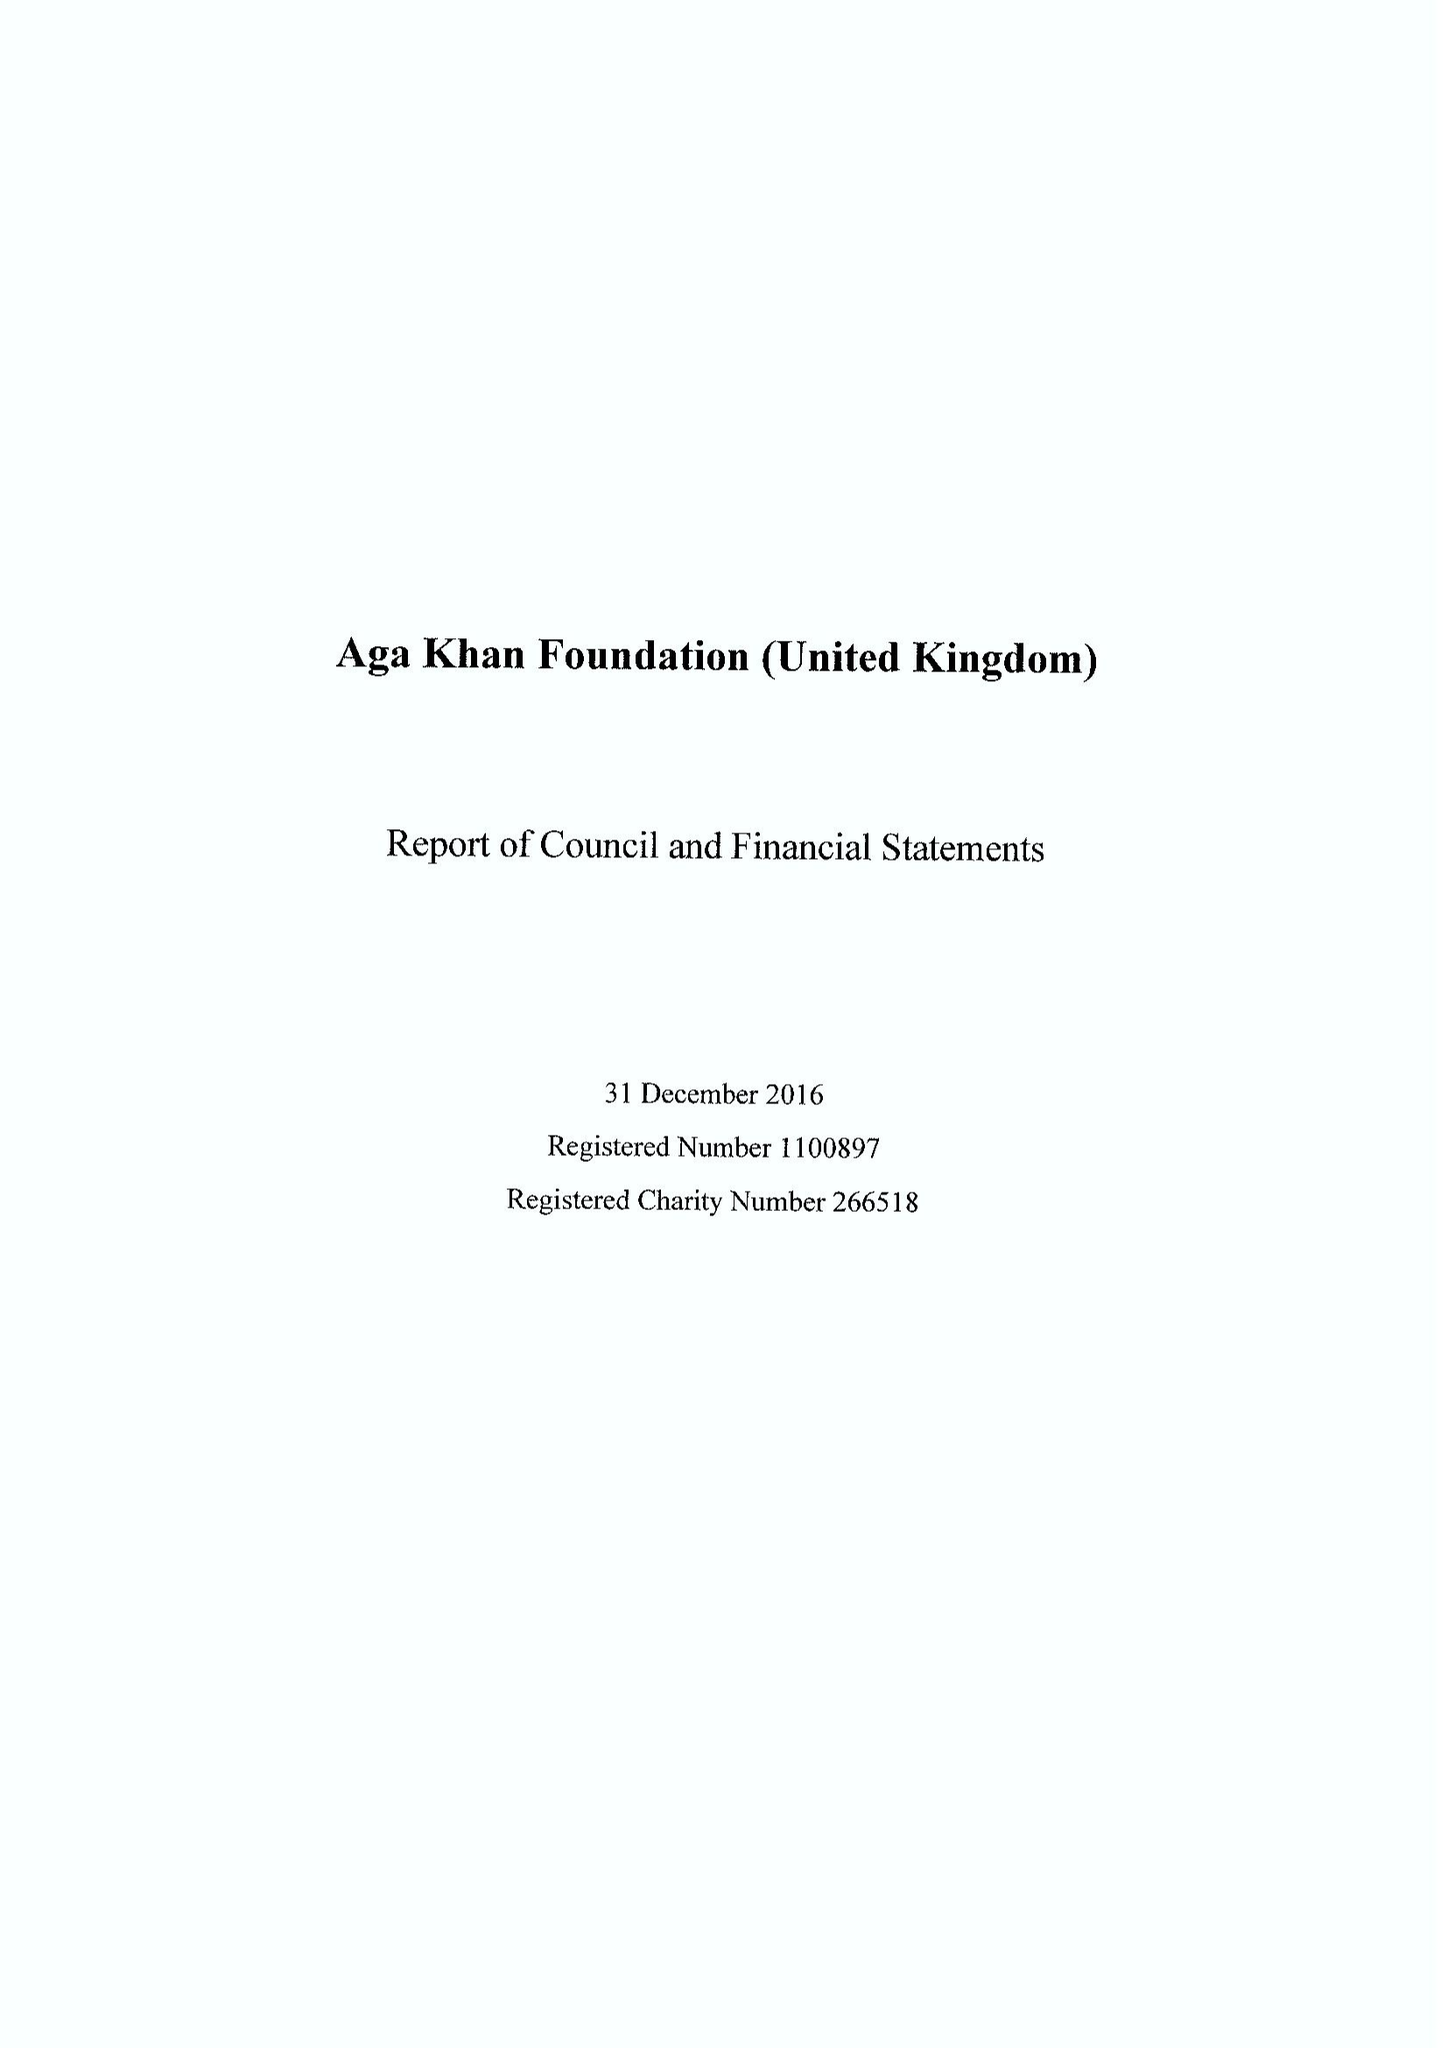What is the value for the income_annually_in_british_pounds?
Answer the question using a single word or phrase. 27983000.00 